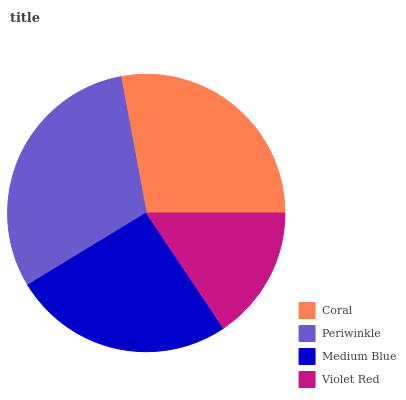Is Violet Red the minimum?
Answer yes or no. Yes. Is Periwinkle the maximum?
Answer yes or no. Yes. Is Medium Blue the minimum?
Answer yes or no. No. Is Medium Blue the maximum?
Answer yes or no. No. Is Periwinkle greater than Medium Blue?
Answer yes or no. Yes. Is Medium Blue less than Periwinkle?
Answer yes or no. Yes. Is Medium Blue greater than Periwinkle?
Answer yes or no. No. Is Periwinkle less than Medium Blue?
Answer yes or no. No. Is Coral the high median?
Answer yes or no. Yes. Is Medium Blue the low median?
Answer yes or no. Yes. Is Periwinkle the high median?
Answer yes or no. No. Is Periwinkle the low median?
Answer yes or no. No. 